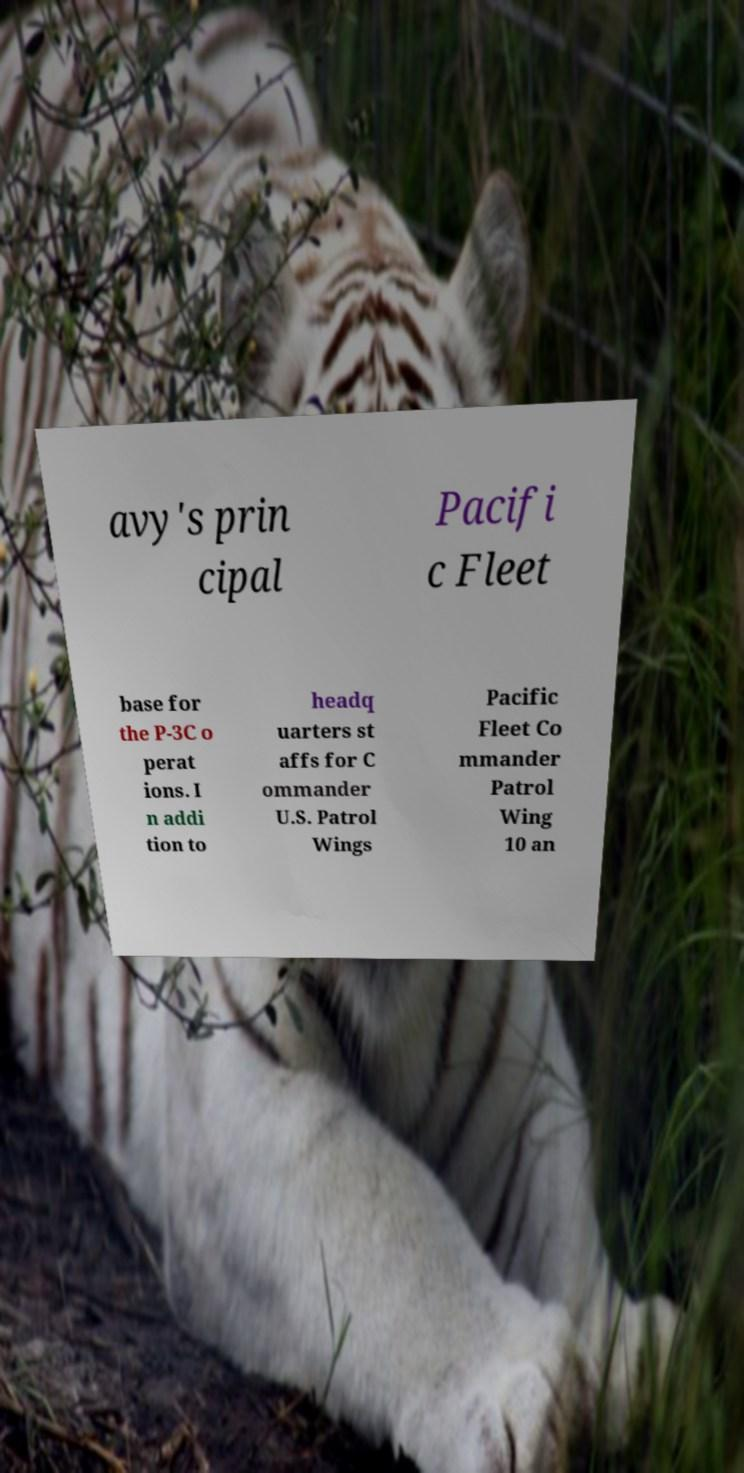For documentation purposes, I need the text within this image transcribed. Could you provide that? avy's prin cipal Pacifi c Fleet base for the P-3C o perat ions. I n addi tion to headq uarters st affs for C ommander U.S. Patrol Wings Pacific Fleet Co mmander Patrol Wing 10 an 